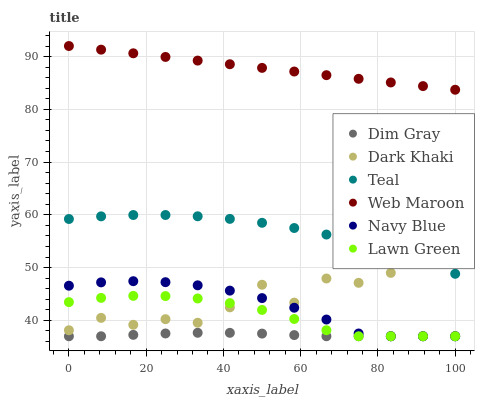Does Dim Gray have the minimum area under the curve?
Answer yes or no. Yes. Does Web Maroon have the maximum area under the curve?
Answer yes or no. Yes. Does Navy Blue have the minimum area under the curve?
Answer yes or no. No. Does Navy Blue have the maximum area under the curve?
Answer yes or no. No. Is Web Maroon the smoothest?
Answer yes or no. Yes. Is Dark Khaki the roughest?
Answer yes or no. Yes. Is Dim Gray the smoothest?
Answer yes or no. No. Is Dim Gray the roughest?
Answer yes or no. No. Does Lawn Green have the lowest value?
Answer yes or no. Yes. Does Web Maroon have the lowest value?
Answer yes or no. No. Does Web Maroon have the highest value?
Answer yes or no. Yes. Does Navy Blue have the highest value?
Answer yes or no. No. Is Navy Blue less than Teal?
Answer yes or no. Yes. Is Teal greater than Lawn Green?
Answer yes or no. Yes. Does Teal intersect Dark Khaki?
Answer yes or no. Yes. Is Teal less than Dark Khaki?
Answer yes or no. No. Is Teal greater than Dark Khaki?
Answer yes or no. No. Does Navy Blue intersect Teal?
Answer yes or no. No. 